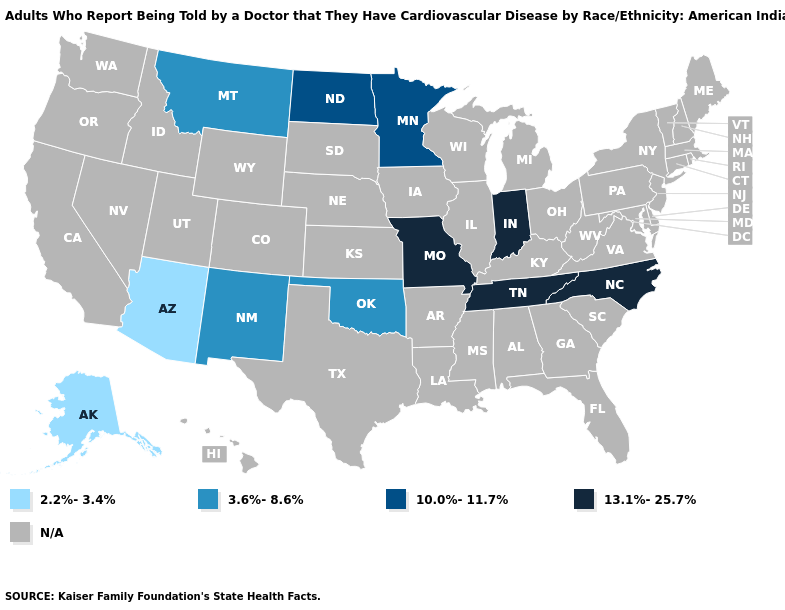Name the states that have a value in the range 13.1%-25.7%?
Concise answer only. Indiana, Missouri, North Carolina, Tennessee. What is the value of South Dakota?
Quick response, please. N/A. Name the states that have a value in the range 3.6%-8.6%?
Be succinct. Montana, New Mexico, Oklahoma. What is the value of Oregon?
Keep it brief. N/A. How many symbols are there in the legend?
Short answer required. 5. What is the lowest value in states that border Virginia?
Keep it brief. 13.1%-25.7%. Name the states that have a value in the range 2.2%-3.4%?
Write a very short answer. Alaska, Arizona. Name the states that have a value in the range N/A?
Concise answer only. Alabama, Arkansas, California, Colorado, Connecticut, Delaware, Florida, Georgia, Hawaii, Idaho, Illinois, Iowa, Kansas, Kentucky, Louisiana, Maine, Maryland, Massachusetts, Michigan, Mississippi, Nebraska, Nevada, New Hampshire, New Jersey, New York, Ohio, Oregon, Pennsylvania, Rhode Island, South Carolina, South Dakota, Texas, Utah, Vermont, Virginia, Washington, West Virginia, Wisconsin, Wyoming. Which states have the lowest value in the USA?
Be succinct. Alaska, Arizona. Name the states that have a value in the range 10.0%-11.7%?
Short answer required. Minnesota, North Dakota. Name the states that have a value in the range 3.6%-8.6%?
Answer briefly. Montana, New Mexico, Oklahoma. What is the lowest value in states that border New Mexico?
Answer briefly. 2.2%-3.4%. Which states have the highest value in the USA?
Short answer required. Indiana, Missouri, North Carolina, Tennessee. 